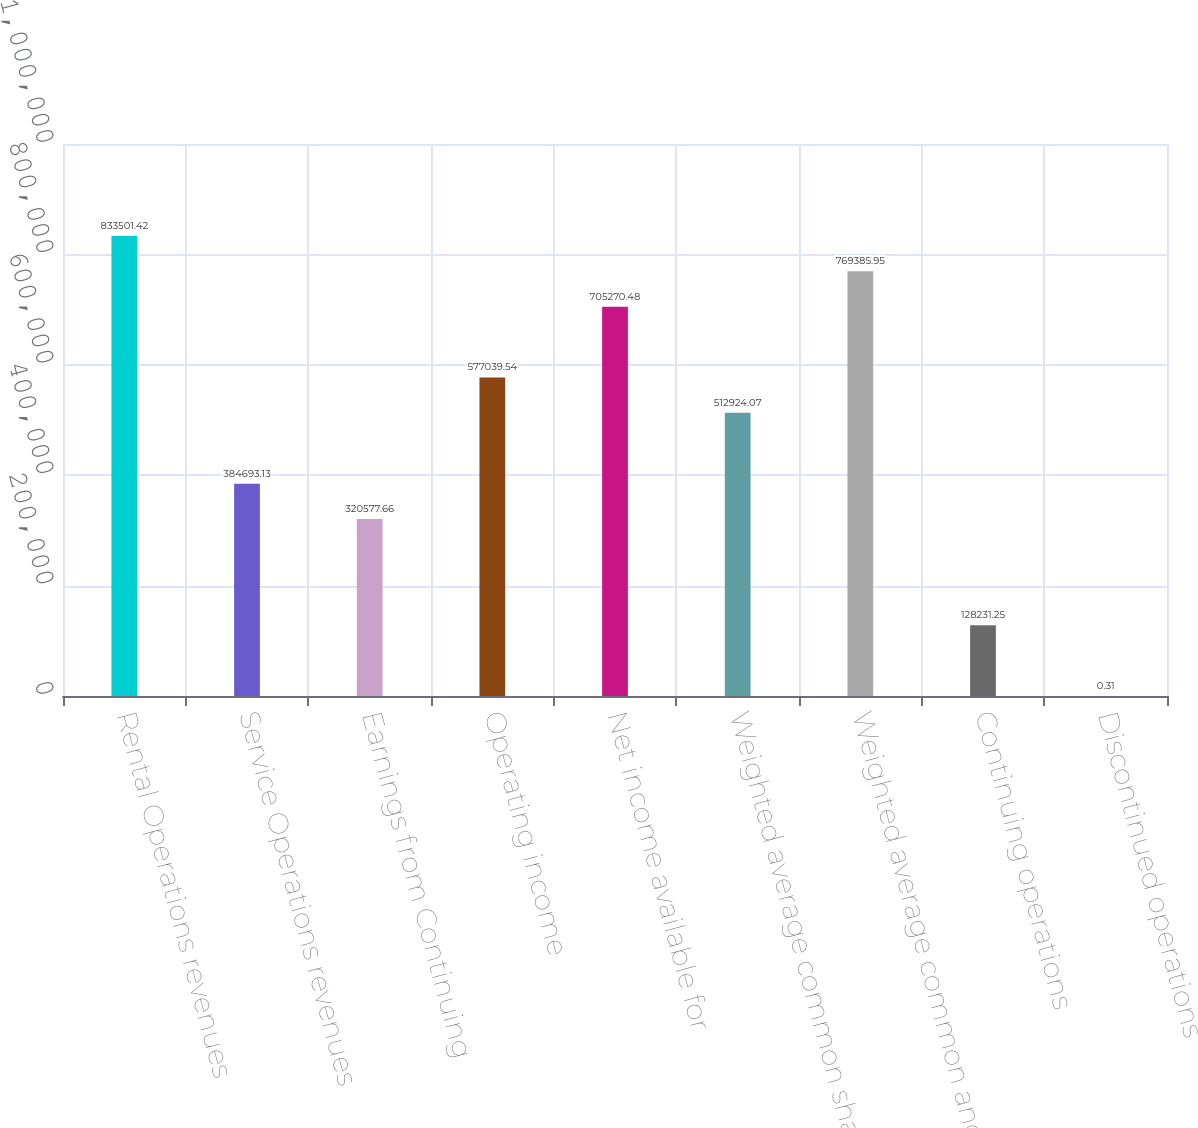<chart> <loc_0><loc_0><loc_500><loc_500><bar_chart><fcel>Rental Operations revenues<fcel>Service Operations revenues<fcel>Earnings from Continuing<fcel>Operating income<fcel>Net income available for<fcel>Weighted average common shares<fcel>Weighted average common and<fcel>Continuing operations<fcel>Discontinued operations<nl><fcel>833501<fcel>384693<fcel>320578<fcel>577040<fcel>705270<fcel>512924<fcel>769386<fcel>128231<fcel>0.31<nl></chart> 